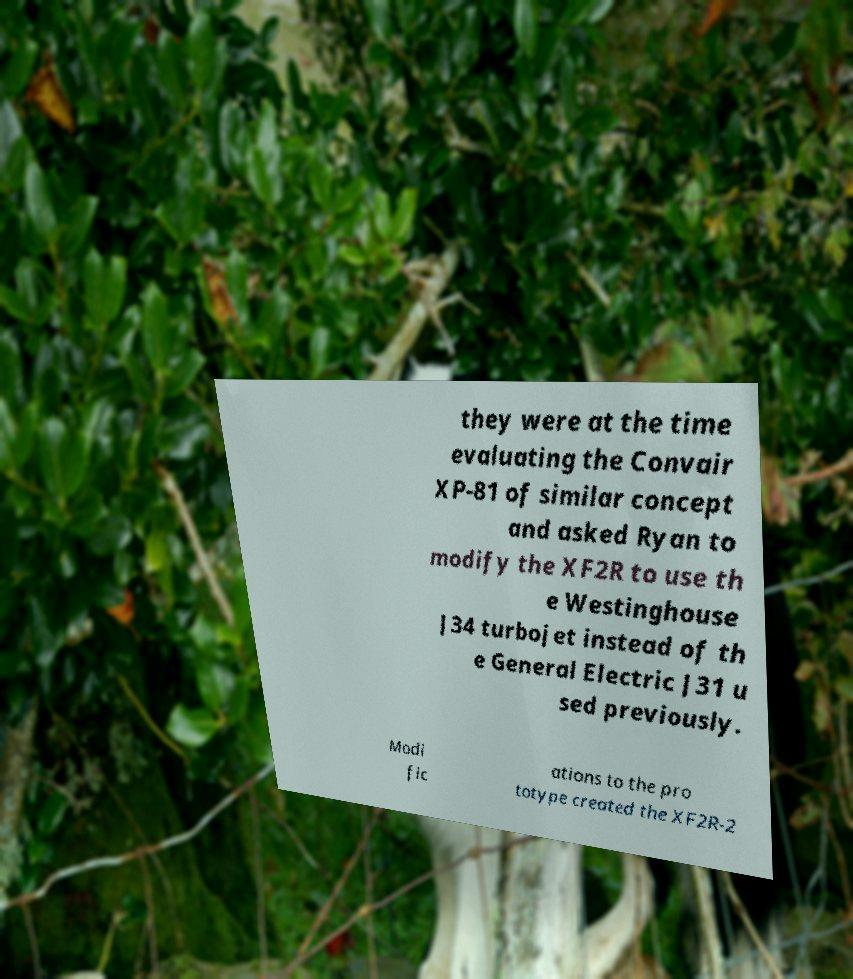Could you assist in decoding the text presented in this image and type it out clearly? they were at the time evaluating the Convair XP-81 of similar concept and asked Ryan to modify the XF2R to use th e Westinghouse J34 turbojet instead of th e General Electric J31 u sed previously. Modi fic ations to the pro totype created the XF2R-2 